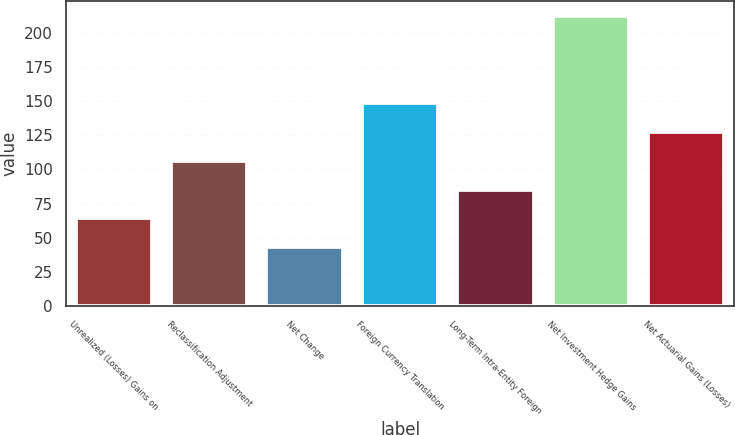Convert chart. <chart><loc_0><loc_0><loc_500><loc_500><bar_chart><fcel>Unrealized (Losses) Gains on<fcel>Reclassification Adjustment<fcel>Net Change<fcel>Foreign Currency Translation<fcel>Long-Term Intra-Entity Foreign<fcel>Net Investment Hedge Gains<fcel>Net Actuarial Gains (Losses)<nl><fcel>64.07<fcel>106.45<fcel>42.88<fcel>148.83<fcel>85.26<fcel>212.4<fcel>127.64<nl></chart> 